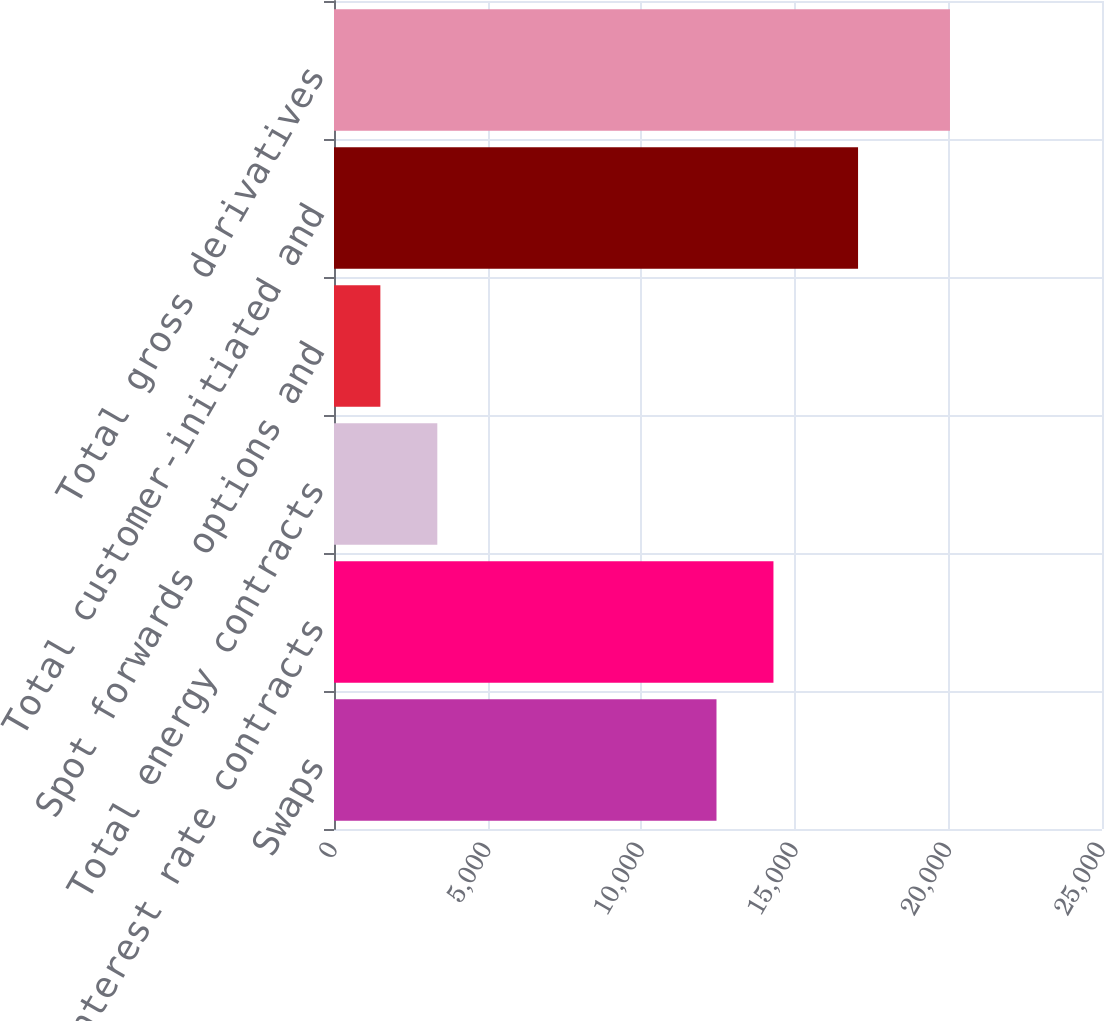Convert chart to OTSL. <chart><loc_0><loc_0><loc_500><loc_500><bar_chart><fcel>Swaps<fcel>Total interest rate contracts<fcel>Total energy contracts<fcel>Spot forwards options and<fcel>Total customer-initiated and<fcel>Total gross derivatives<nl><fcel>12451<fcel>14305.2<fcel>3363.2<fcel>1509<fcel>17059<fcel>20051<nl></chart> 